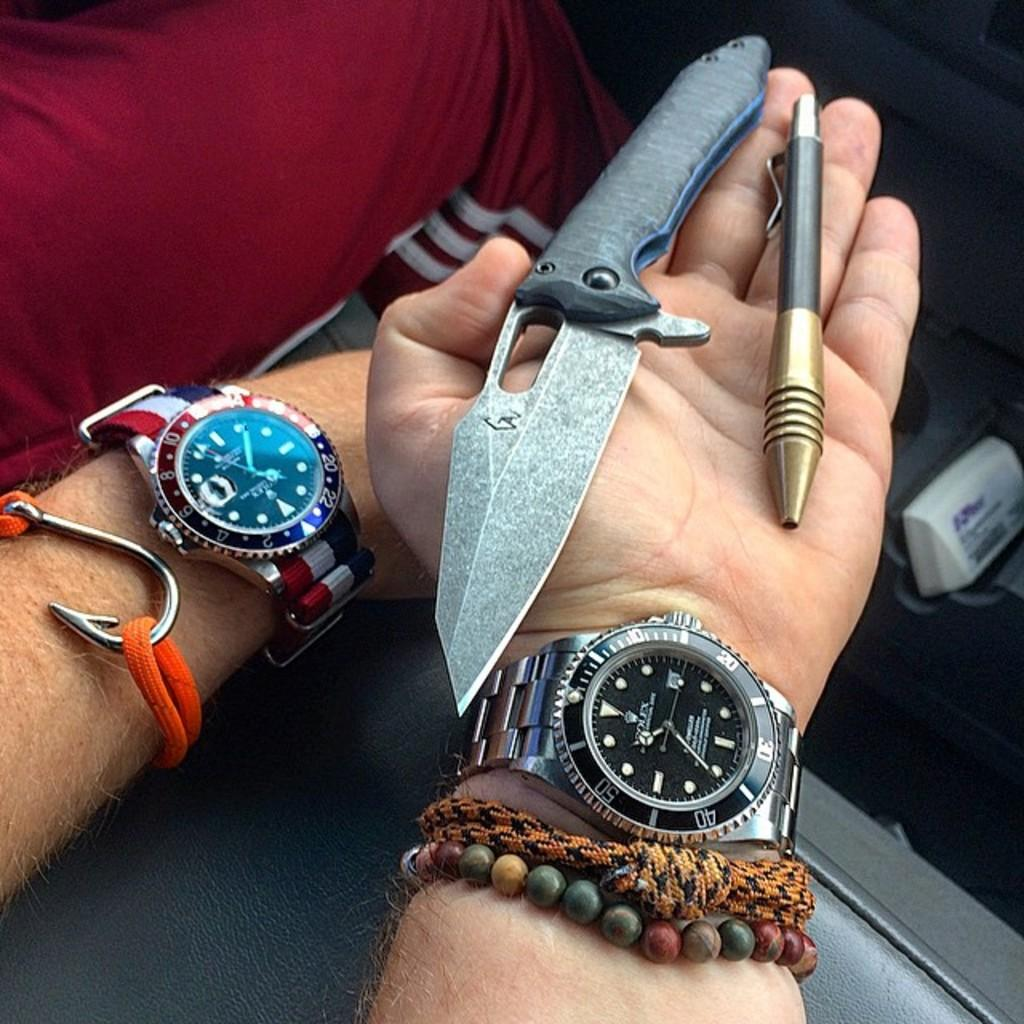Provide a one-sentence caption for the provided image. A person with a Rolex on their wrist holding a pen and a knife in their hand. 